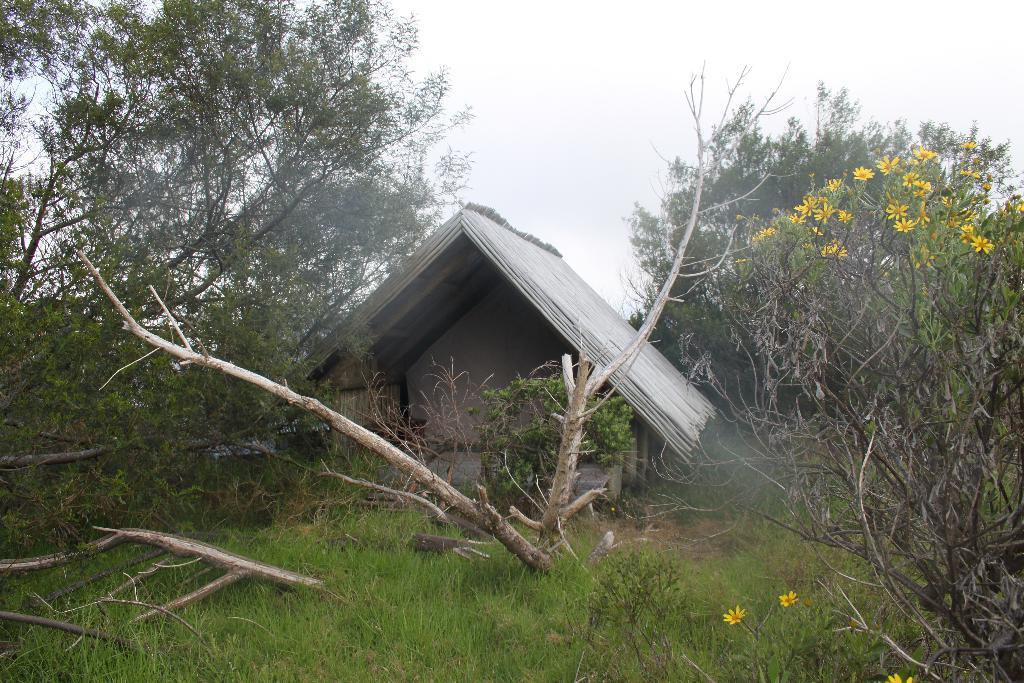Could you give a brief overview of what you see in this image? In this picture we can see a shed, grass, few trees and flowers. 